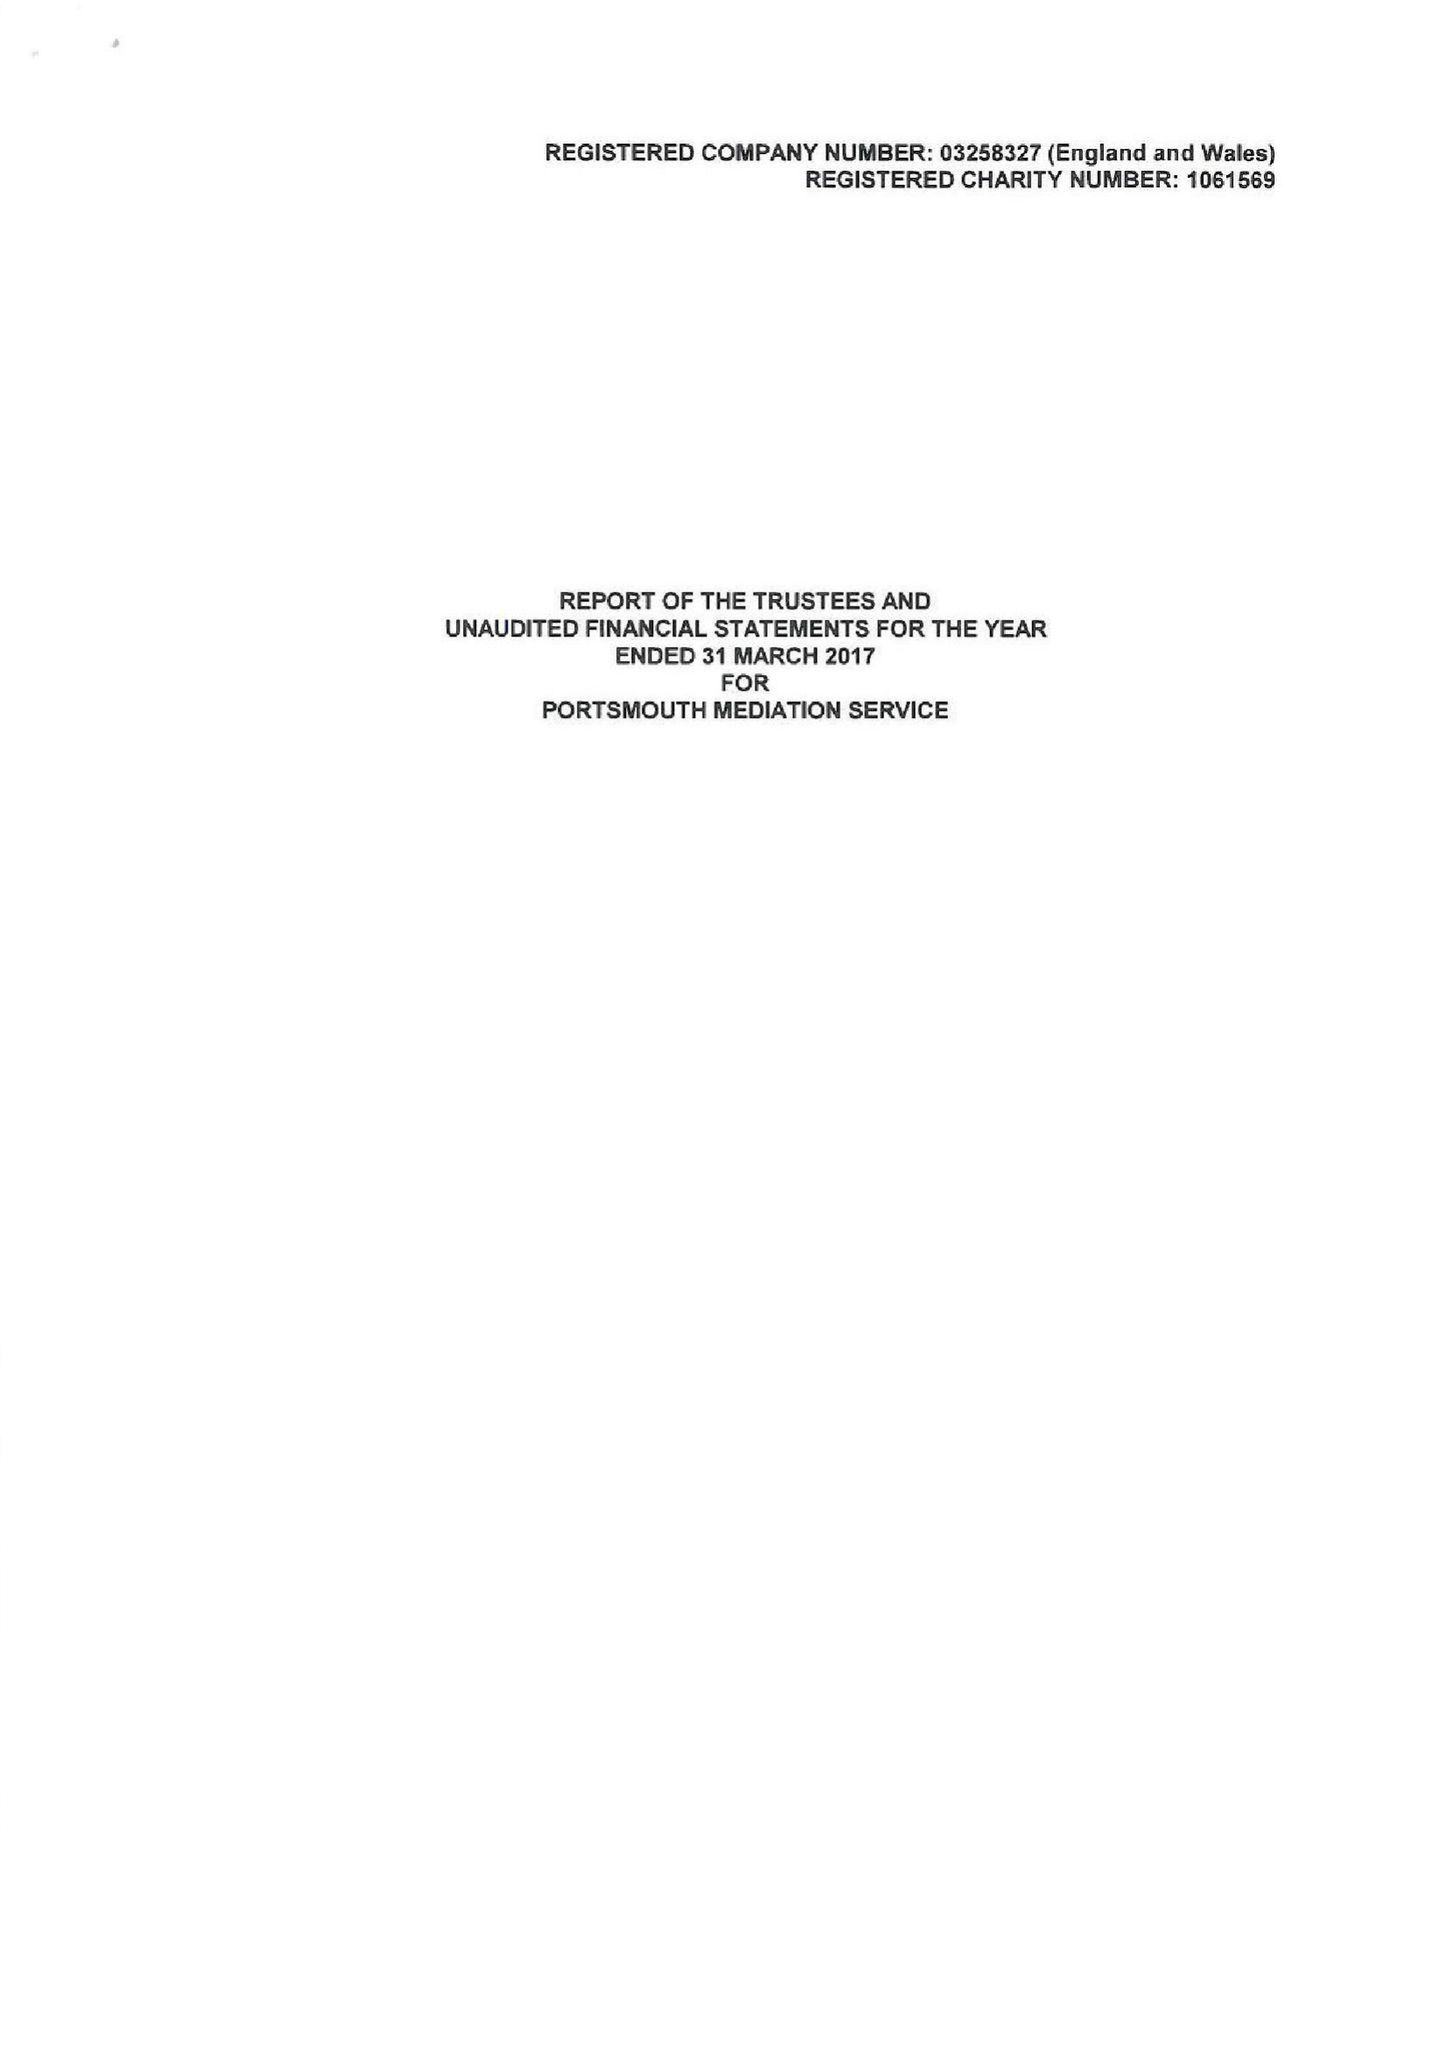What is the value for the charity_number?
Answer the question using a single word or phrase. 1061569 